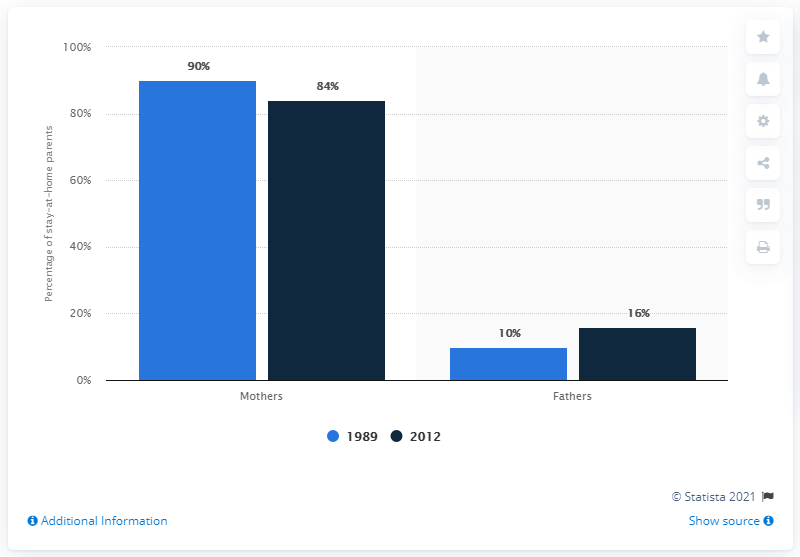Highlight a few significant elements in this photo. The percentage difference between the ages of the two fathers is 6%. In the year 1989, a significant percentage of parents chose to stay at home. 